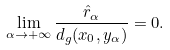<formula> <loc_0><loc_0><loc_500><loc_500>\lim _ { \alpha \rightarrow + \infty } \frac { \hat { r } _ { \alpha } } { d _ { g } ( x _ { 0 } , y _ { \alpha } ) } = 0 .</formula> 